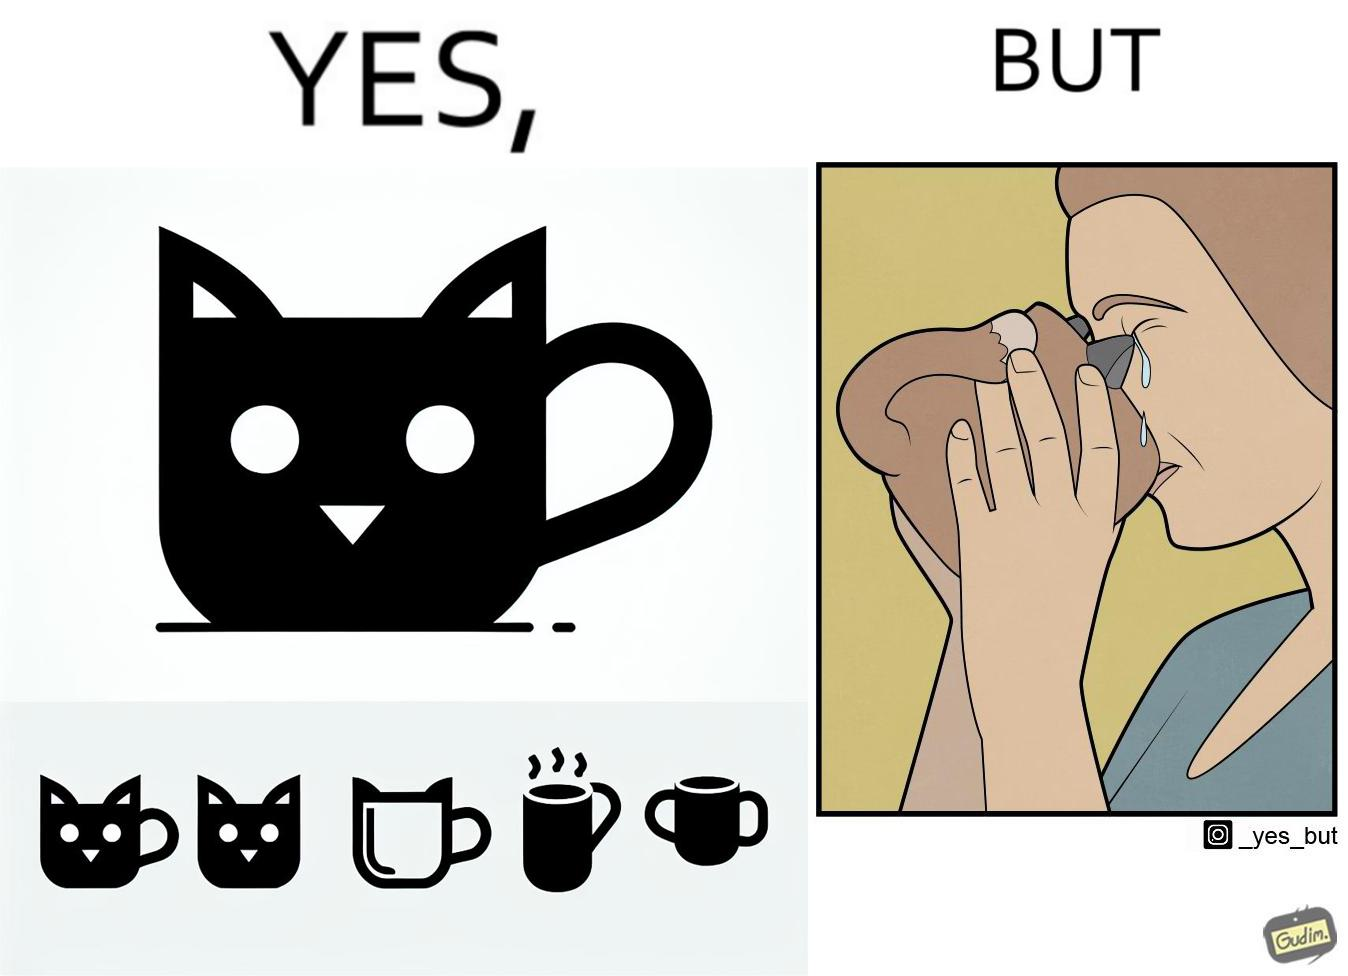What is shown in the left half versus the right half of this image? In the left part of the image: A mug that looks like a cat's face and has cat's facial features like ears In the right part of the image: a woman drinking from a mug and crying because something on the mug is poking in her face 